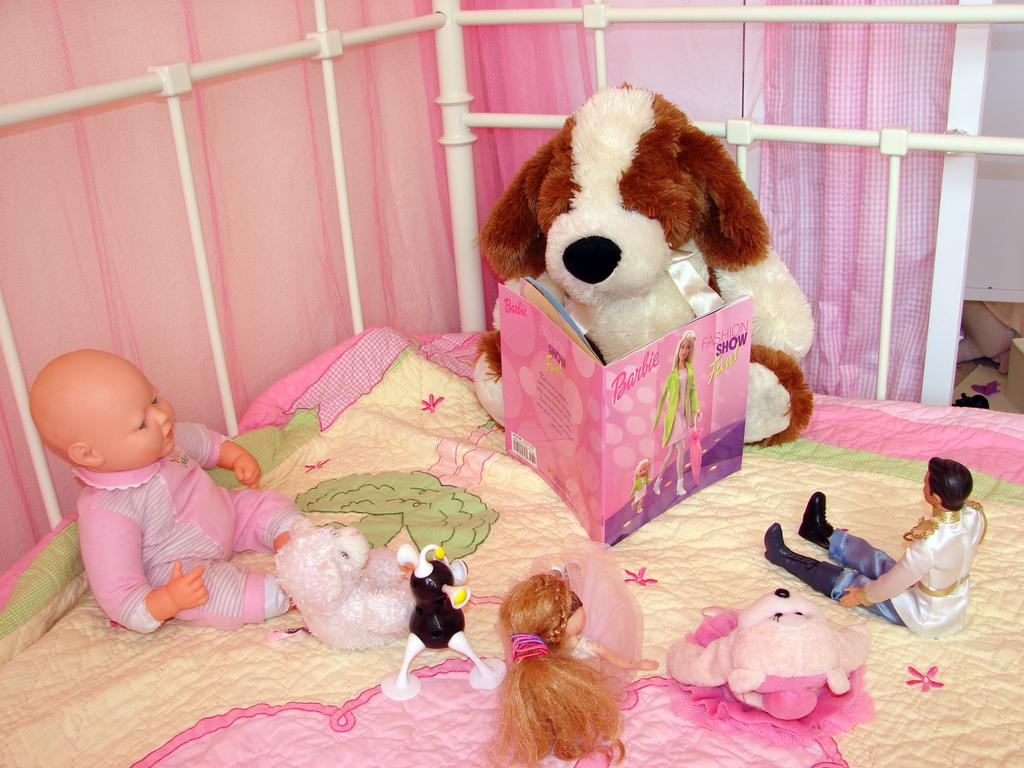What is present on the bed sheet in the image? There is a baby toy on the bed sheet in the image. Who is in the image? There is a man in the image. What type of toys are present in the image? There are girl toys in the image. What can be seen in the image that might be used for reading? There is a book in the image. What type of structure is visible in the image with rods? There is a fence with rods in the image. What type of window treatment is present in the image? There are curtains in the image. What type of oil is being used to lubricate the fence rods in the image? There is no oil or lubrication mentioned in the image; it only shows a fence with rods. What degree does the woman in the image have? There is no woman present in the image, so it is not possible to determine her degree. 